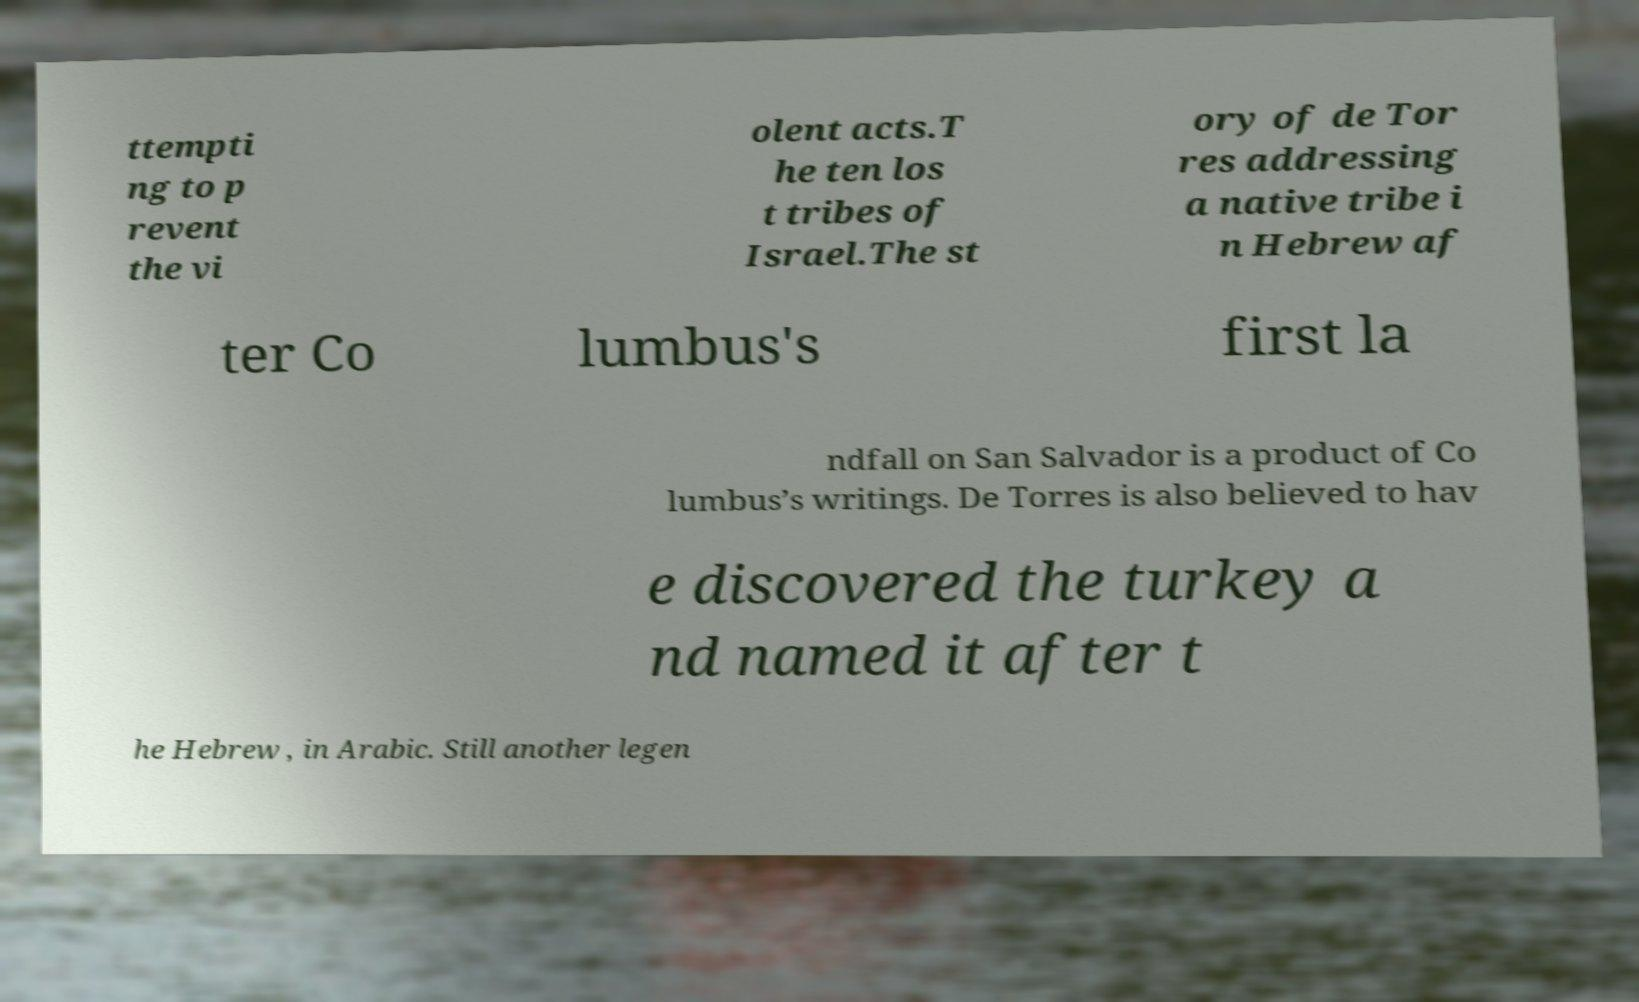Could you assist in decoding the text presented in this image and type it out clearly? ttempti ng to p revent the vi olent acts.T he ten los t tribes of Israel.The st ory of de Tor res addressing a native tribe i n Hebrew af ter Co lumbus's first la ndfall on San Salvador is a product of Co lumbus’s writings. De Torres is also believed to hav e discovered the turkey a nd named it after t he Hebrew , in Arabic. Still another legen 